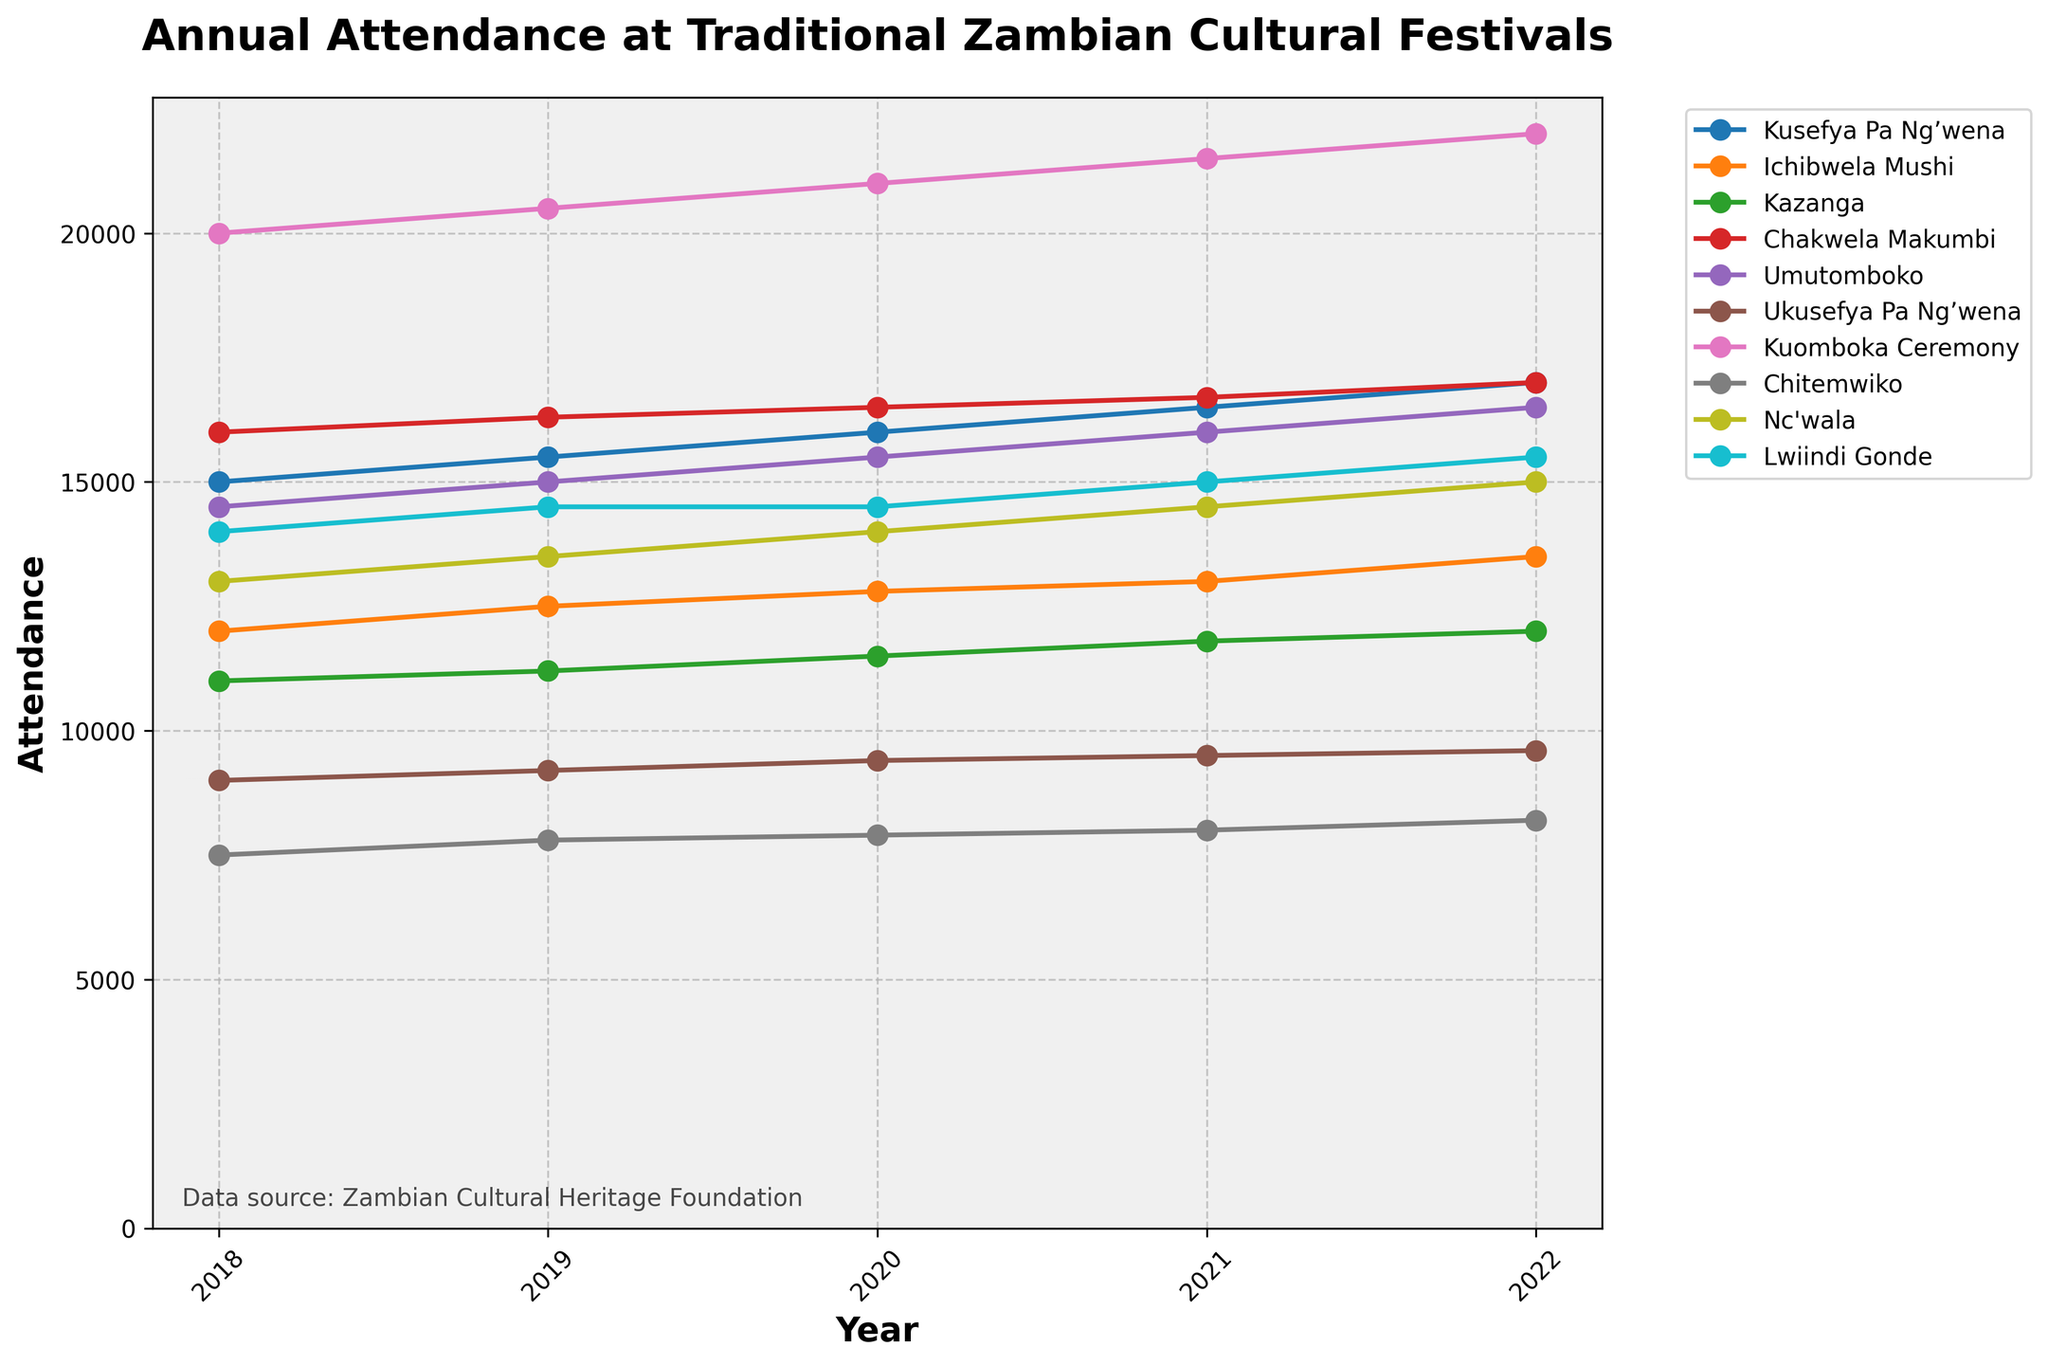What is the title of the plot? The title is the text in large, bold characters at the top of the figure. It provides a summary of what the plot represents.
Answer: Annual Attendance at Traditional Zambian Cultural Festivals Which festival had the highest attendance in 2022? Look for the year 2022 on the x-axis, then check the corresponding y-values of all festivals. The highest y-value represents the highest attendance.
Answer: Kuomboka Ceremony How has the attendance trend for the Kuomboka Ceremony changed from 2018 to 2022? Identify the line representing the Kuomboka Ceremony, then observe how it progresses from 2018 to 2022. Check if it is generally increasing, decreasing, or staying constant.
Answer: Increased from 20000 to 22000 What is the average attendance for Chakwela Makumbi over the 5 years? Find all y-values for Chakwela Makumbi from 2018 to 2022. Sum these values and divide by the number of years (5) to get the average.
Answer: 16500 Which festival in the Copperbelt Province saw the lowest attendance and in which year? Find the line corresponding to the Copperbelt Province festival, then locate the point with the lowest y-value and note the corresponding year on the x-axis.
Answer: Ichibwela Mushi in 2018 Compare the attendance of Nc'wala and Lwiindi Gonde in 2021. Which was higher? Find the attendance data points for Nc'wala and Lwiindi Gonde in 2021 and compare their y-values. The higher y-value indicates the festival with higher attendance.
Answer: Nc'wala Which festival shows the most consistent attendance over the years? Look for the line that has the smallest fluctuation (most horizontal) across the years. This indicates consistency in attendance.
Answer: Lwiindi Gonde By how much did the attendance of Chitemwiko change between 2018 and 2022? Subtract the y-value of Chitemwiko in 2018 from its y-value in 2022 to find the change in attendance.
Answer: Increased by 700 What is the festival with the highest increase in attendance from 2018 to 2022? For each festival, subtract the 2018 attendance from the 2022 attendance. The highest difference indicates the festival with the highest increase.
Answer: Kusefya Pa Ng’wena How does the attendance change for Umutomboko from 2020 to 2021? Check the y-values for Umutomboko in 2020 and 2021 and note the difference.
Answer: Increased by 500 